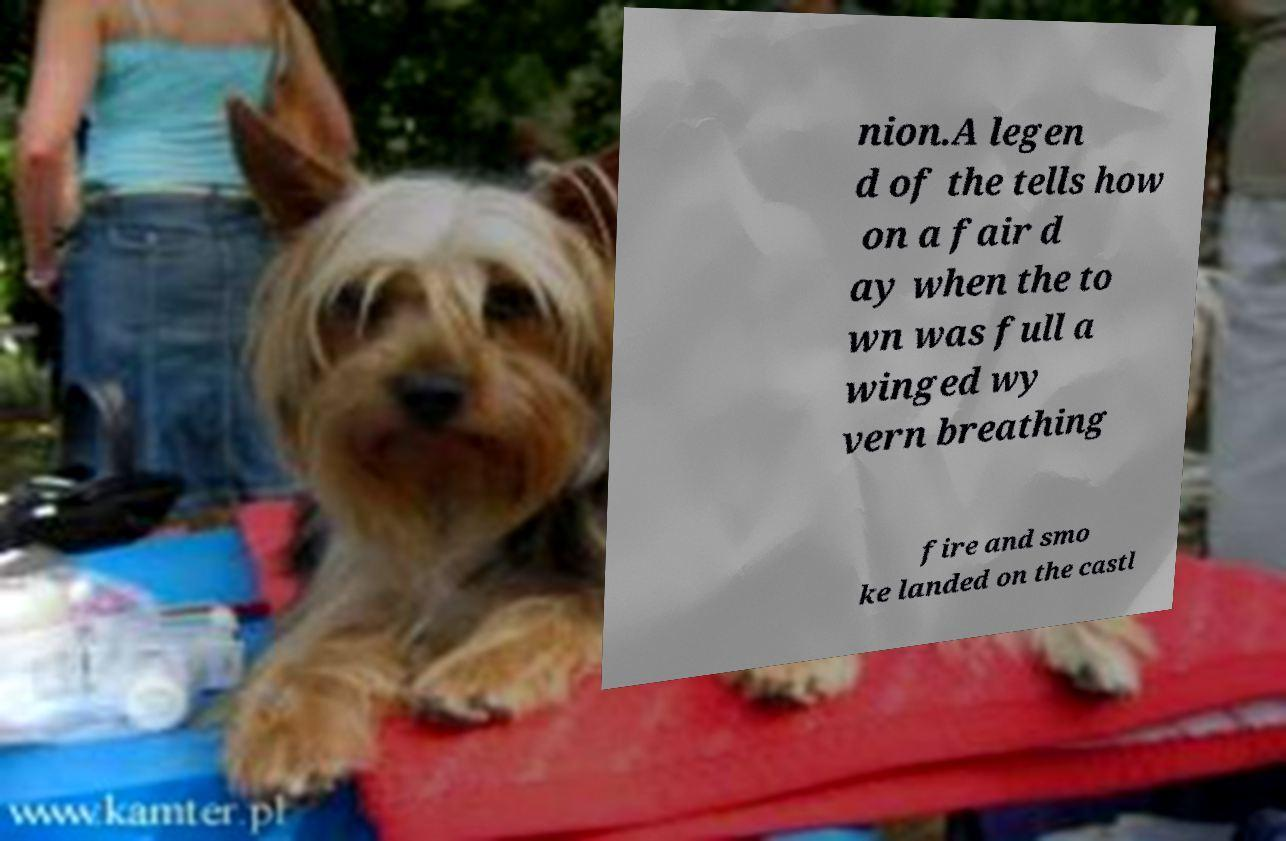There's text embedded in this image that I need extracted. Can you transcribe it verbatim? nion.A legen d of the tells how on a fair d ay when the to wn was full a winged wy vern breathing fire and smo ke landed on the castl 